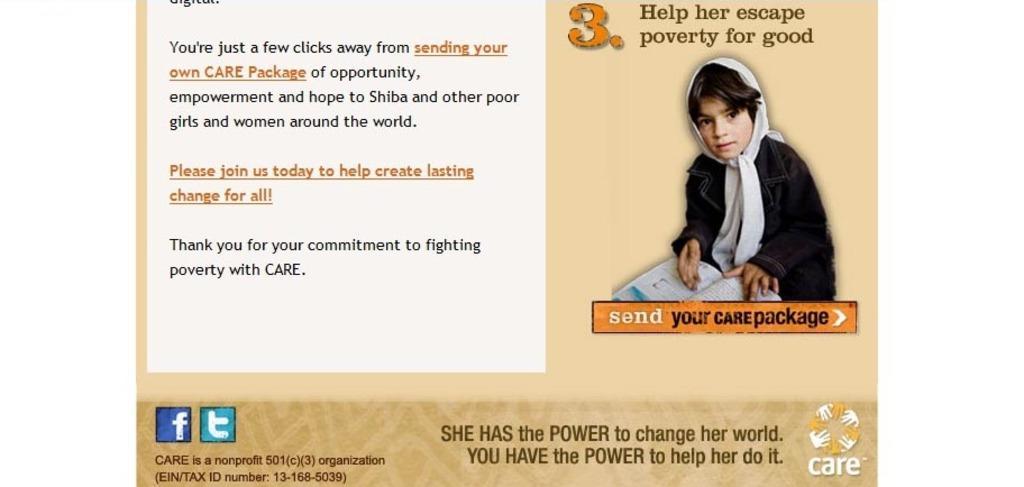Describe this image in one or two sentences. In the image we can see a web page. In the web page we can see a girl is holding a book. 